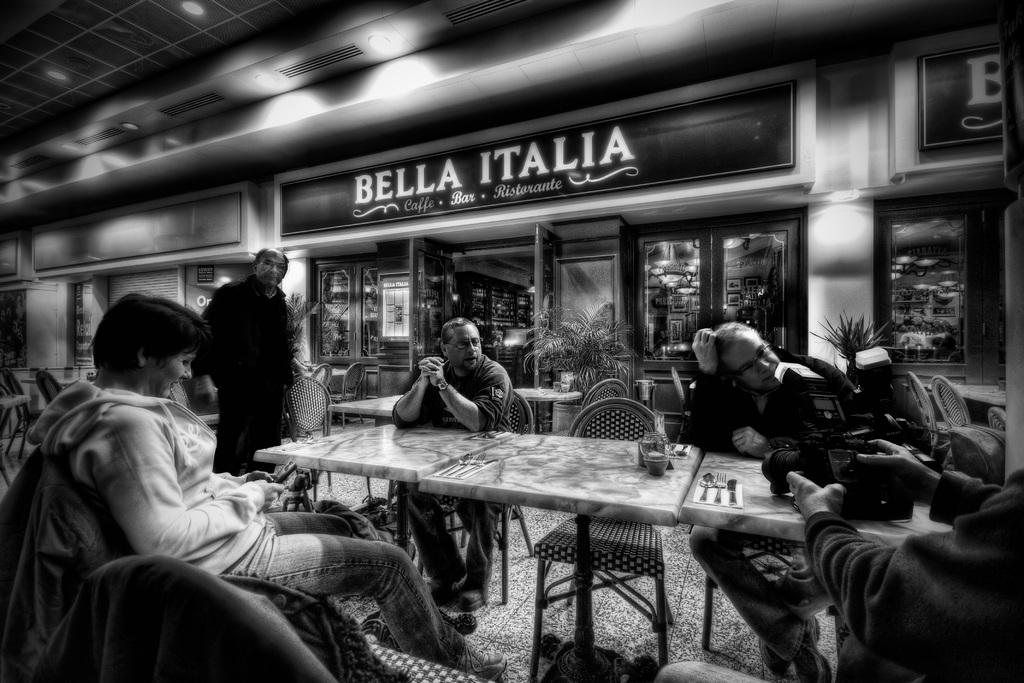What are the people in the image doing? The people in the image are sitting on chairs. What is in front of the people? There is a table in front of the people. What can be found on the table? There are objects on the table. What can be seen in the background of the image? There is a building visible in the image. What is the price of the skate on the table in the image? There is no skate present on the table in the image. 